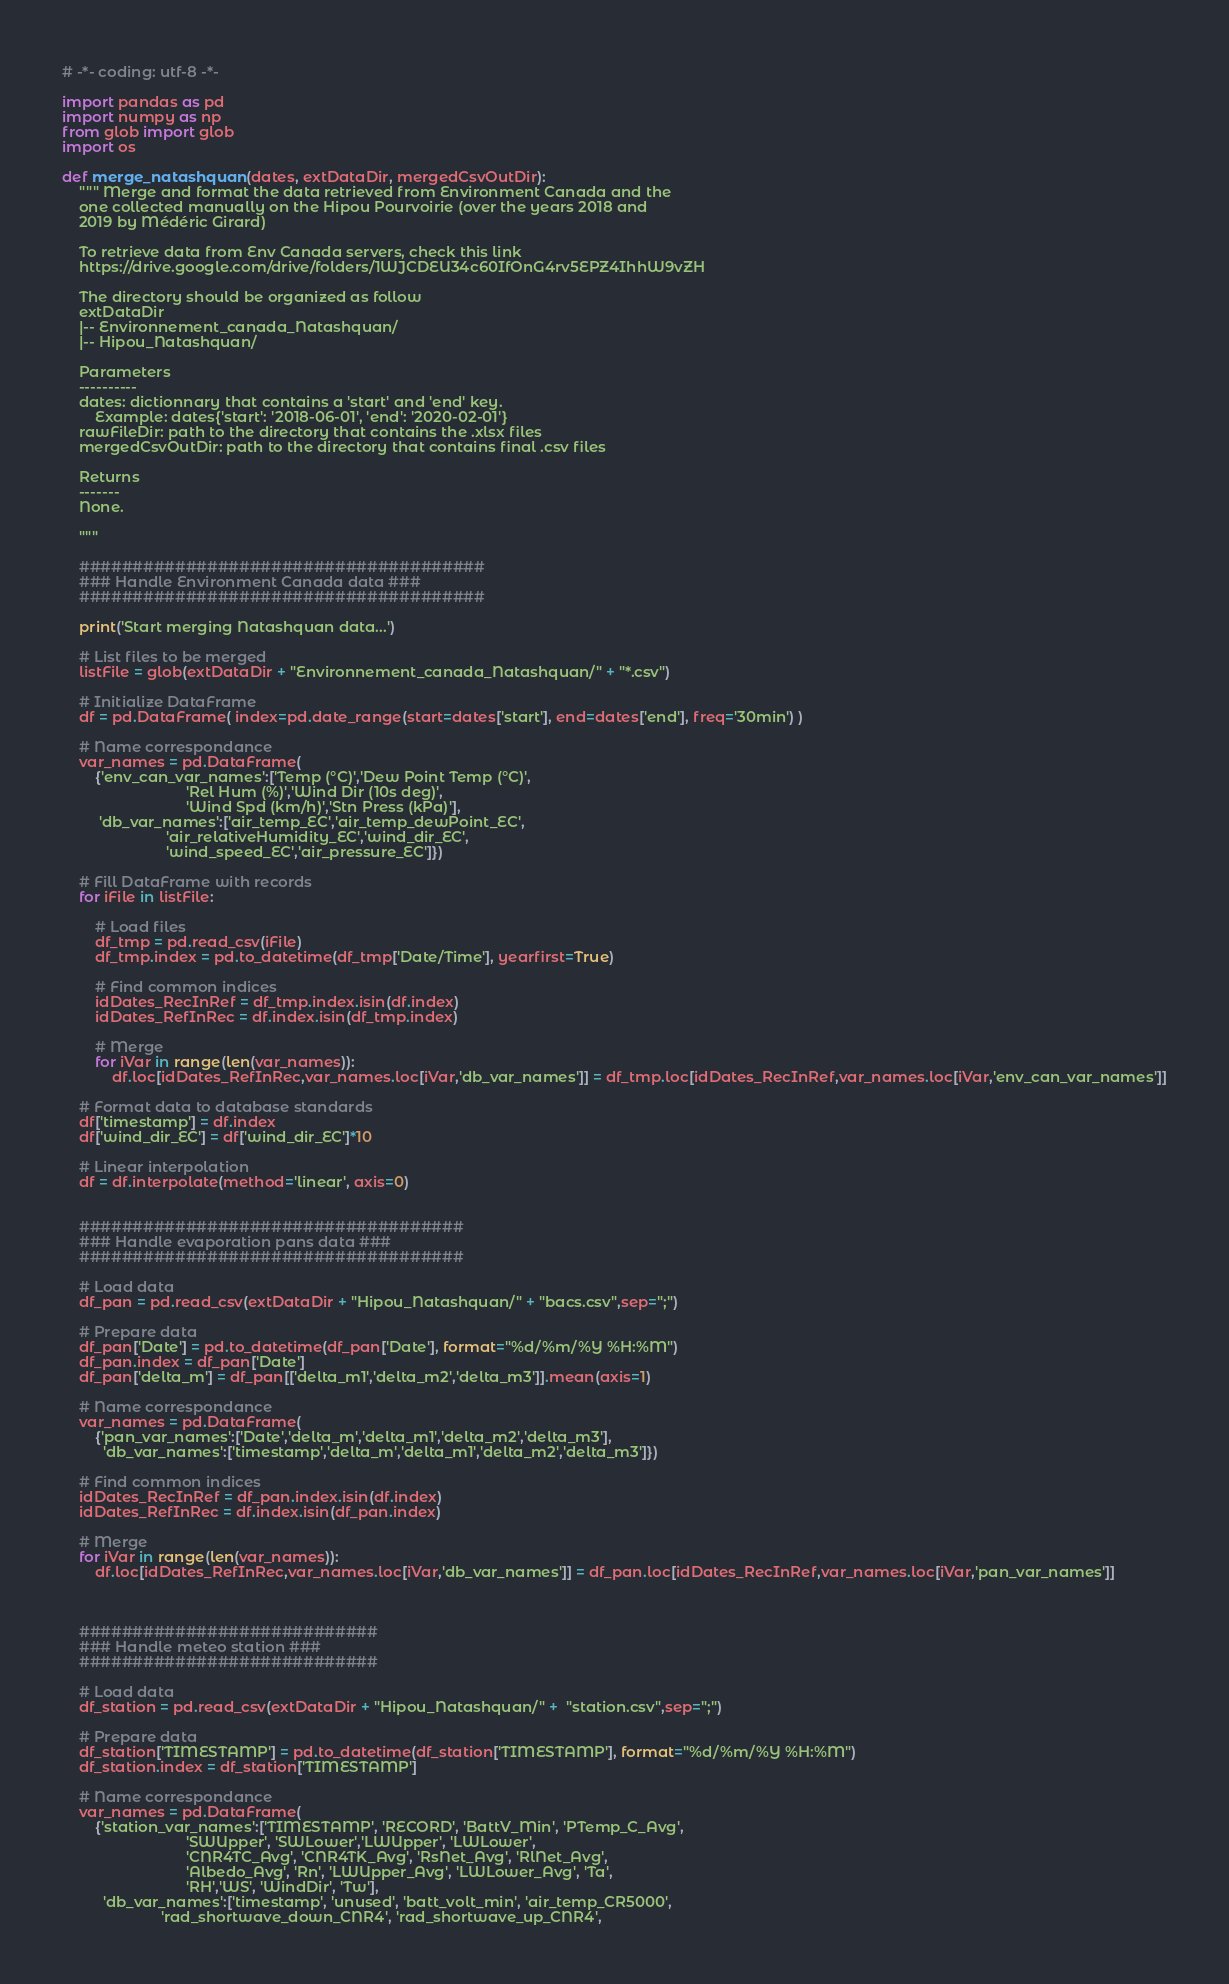<code> <loc_0><loc_0><loc_500><loc_500><_Python_># -*- coding: utf-8 -*-

import pandas as pd
import numpy as np
from glob import glob
import os

def merge_natashquan(dates, extDataDir, mergedCsvOutDir):
    """ Merge and format the data retrieved from Environment Canada and the
    one collected manually on the Hipou Pourvoirie (over the years 2018 and
    2019 by Médéric Girard)

    To retrieve data from Env Canada servers, check this link
    https://drive.google.com/drive/folders/1WJCDEU34c60IfOnG4rv5EPZ4IhhW9vZH

    The directory should be organized as follow
    extDataDir
    |-- Environnement_canada_Natashquan/
    |-- Hipou_Natashquan/

    Parameters
    ----------
    dates: dictionnary that contains a 'start' and 'end' key.
        Example: dates{'start': '2018-06-01', 'end': '2020-02-01'}
    rawFileDir: path to the directory that contains the .xlsx files
    mergedCsvOutDir: path to the directory that contains final .csv files

    Returns
    -------
    None.

    """

    ######################################
    ### Handle Environment Canada data ###
    ######################################

    print('Start merging Natashquan data...')

    # List files to be merged
    listFile = glob(extDataDir + "Environnement_canada_Natashquan/" + "*.csv")

    # Initialize DataFrame
    df = pd.DataFrame( index=pd.date_range(start=dates['start'], end=dates['end'], freq='30min') )

    # Name correspondance
    var_names = pd.DataFrame(
        {'env_can_var_names':['Temp (°C)','Dew Point Temp (°C)',
                              'Rel Hum (%)','Wind Dir (10s deg)',
                              'Wind Spd (km/h)','Stn Press (kPa)'],
         'db_var_names':['air_temp_EC','air_temp_dewPoint_EC',
                         'air_relativeHumidity_EC','wind_dir_EC',
                         'wind_speed_EC','air_pressure_EC']})

    # Fill DataFrame with records
    for iFile in listFile:

        # Load files
        df_tmp = pd.read_csv(iFile)
        df_tmp.index = pd.to_datetime(df_tmp['Date/Time'], yearfirst=True)

        # Find common indices
        idDates_RecInRef = df_tmp.index.isin(df.index)
        idDates_RefInRec = df.index.isin(df_tmp.index)

        # Merge
        for iVar in range(len(var_names)):
            df.loc[idDates_RefInRec,var_names.loc[iVar,'db_var_names']] = df_tmp.loc[idDates_RecInRef,var_names.loc[iVar,'env_can_var_names']]

    # Format data to database standards
    df['timestamp'] = df.index
    df['wind_dir_EC'] = df['wind_dir_EC']*10

    # Linear interpolation
    df = df.interpolate(method='linear', axis=0)


    ####################################
    ### Handle evaporation pans data ###
    ####################################

    # Load data
    df_pan = pd.read_csv(extDataDir + "Hipou_Natashquan/" + "bacs.csv",sep=";")

    # Prepare data
    df_pan['Date'] = pd.to_datetime(df_pan['Date'], format="%d/%m/%Y %H:%M")
    df_pan.index = df_pan['Date']
    df_pan['delta_m'] = df_pan[['delta_m1','delta_m2','delta_m3']].mean(axis=1)

    # Name correspondance
    var_names = pd.DataFrame(
        {'pan_var_names':['Date','delta_m','delta_m1','delta_m2','delta_m3'],
          'db_var_names':['timestamp','delta_m','delta_m1','delta_m2','delta_m3']})

    # Find common indices
    idDates_RecInRef = df_pan.index.isin(df.index)
    idDates_RefInRec = df.index.isin(df_pan.index)

    # Merge
    for iVar in range(len(var_names)):
        df.loc[idDates_RefInRec,var_names.loc[iVar,'db_var_names']] = df_pan.loc[idDates_RecInRef,var_names.loc[iVar,'pan_var_names']]



    ############################
    ### Handle meteo station ###
    ############################

    # Load data
    df_station = pd.read_csv(extDataDir + "Hipou_Natashquan/" +  "station.csv",sep=";")

    # Prepare data
    df_station['TIMESTAMP'] = pd.to_datetime(df_station['TIMESTAMP'], format="%d/%m/%Y %H:%M")
    df_station.index = df_station['TIMESTAMP']

    # Name correspondance
    var_names = pd.DataFrame(
        {'station_var_names':['TIMESTAMP', 'RECORD', 'BattV_Min', 'PTemp_C_Avg',
                              'SWUpper', 'SWLower','LWUpper', 'LWLower',
                              'CNR4TC_Avg', 'CNR4TK_Avg', 'RsNet_Avg', 'RlNet_Avg',
                              'Albedo_Avg', 'Rn', 'LWUpper_Avg', 'LWLower_Avg', 'Ta',
                              'RH','WS', 'WindDir', 'Tw'],
          'db_var_names':['timestamp', 'unused', 'batt_volt_min', 'air_temp_CR5000',
                        'rad_shortwave_down_CNR4', 'rad_shortwave_up_CNR4',</code> 